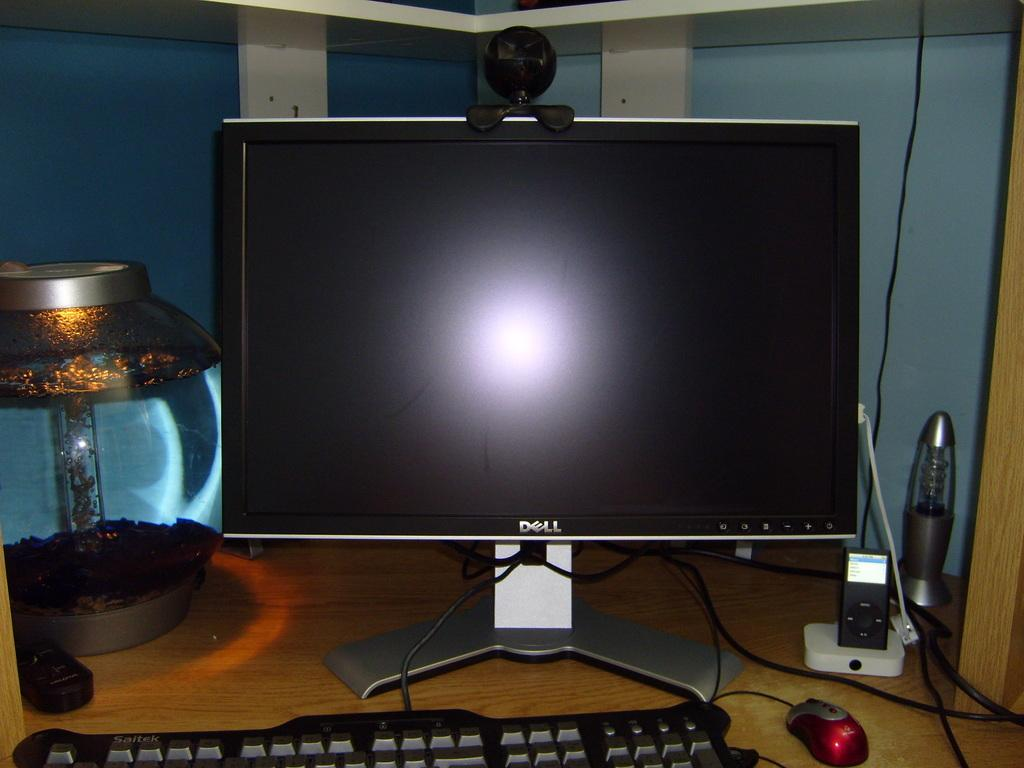<image>
Summarize the visual content of the image. Dell computer monitor with a black screen on a table. 